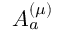<formula> <loc_0><loc_0><loc_500><loc_500>A _ { a } ^ { ( \mu ) }</formula> 